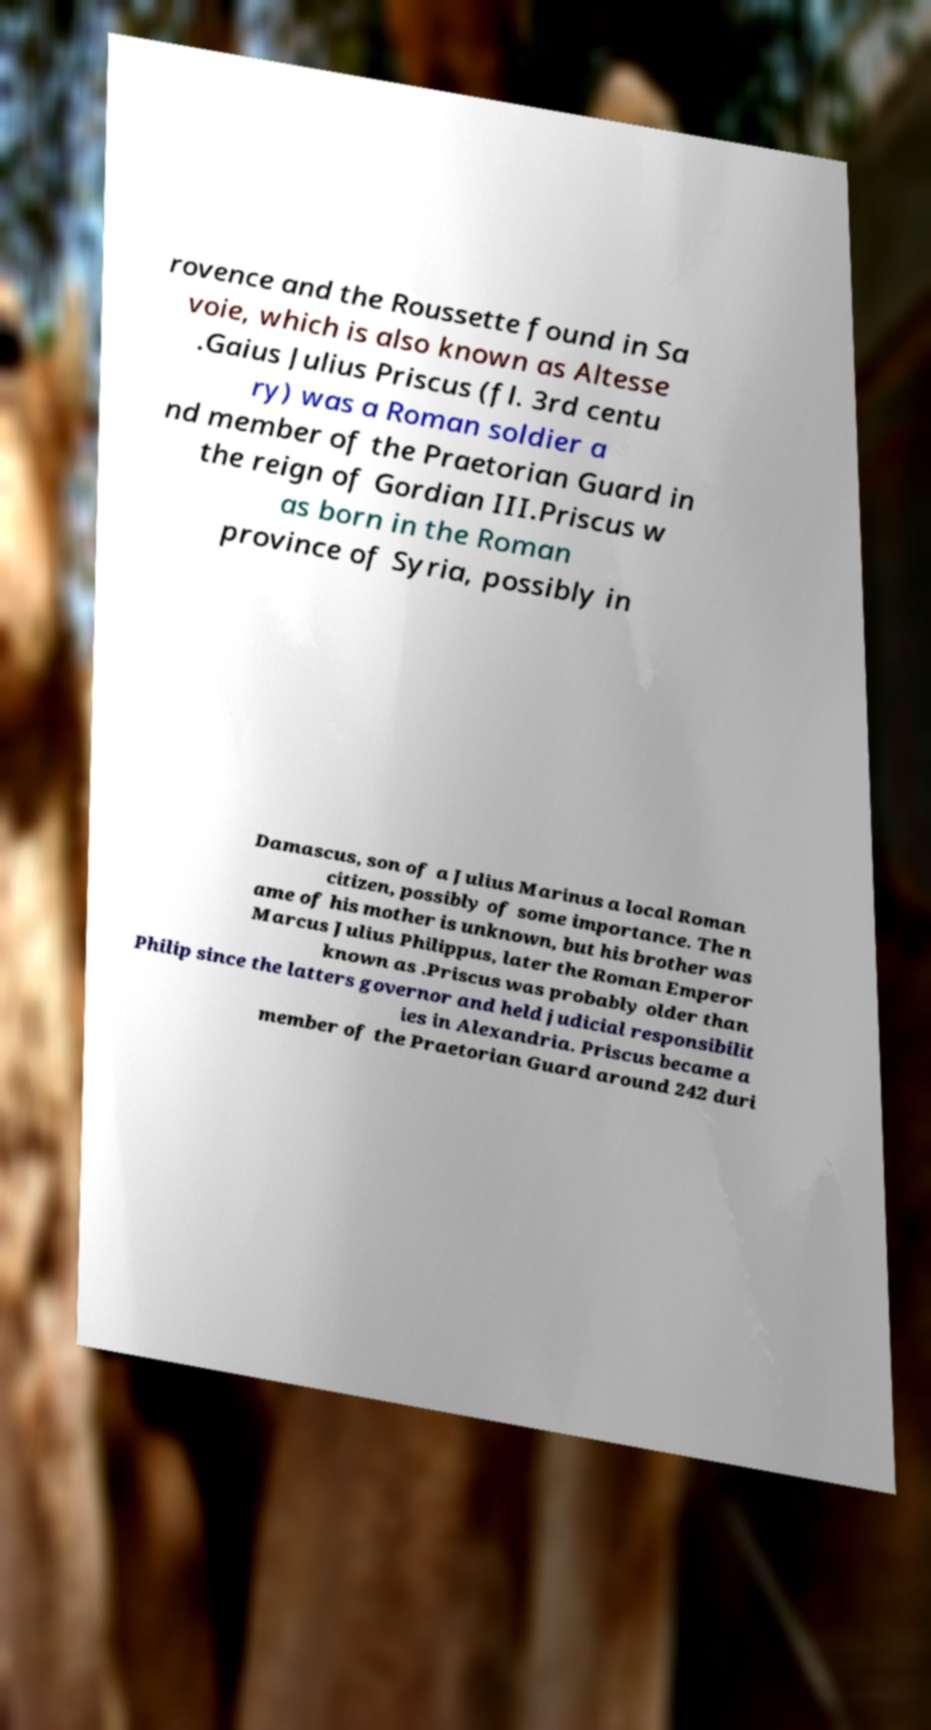I need the written content from this picture converted into text. Can you do that? rovence and the Roussette found in Sa voie, which is also known as Altesse .Gaius Julius Priscus (fl. 3rd centu ry) was a Roman soldier a nd member of the Praetorian Guard in the reign of Gordian III.Priscus w as born in the Roman province of Syria, possibly in Damascus, son of a Julius Marinus a local Roman citizen, possibly of some importance. The n ame of his mother is unknown, but his brother was Marcus Julius Philippus, later the Roman Emperor known as .Priscus was probably older than Philip since the latters governor and held judicial responsibilit ies in Alexandria. Priscus became a member of the Praetorian Guard around 242 duri 